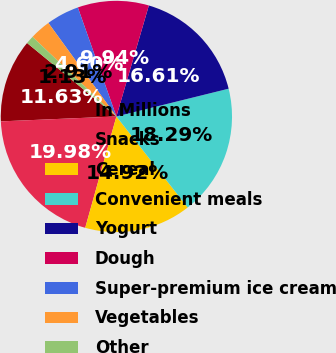Convert chart to OTSL. <chart><loc_0><loc_0><loc_500><loc_500><pie_chart><fcel>In Millions<fcel>Snacks<fcel>Cereal<fcel>Convenient meals<fcel>Yogurt<fcel>Dough<fcel>Super-premium ice cream<fcel>Vegetables<fcel>Other<nl><fcel>11.63%<fcel>19.98%<fcel>14.92%<fcel>18.29%<fcel>16.61%<fcel>9.94%<fcel>4.6%<fcel>2.91%<fcel>1.13%<nl></chart> 